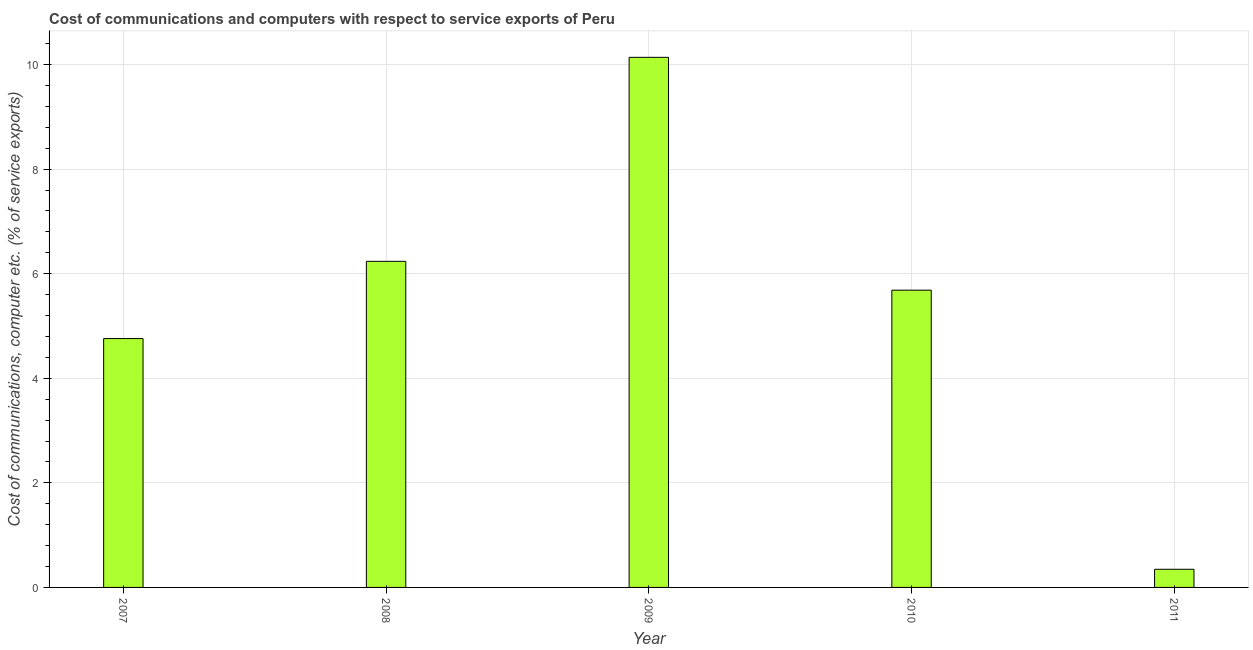Does the graph contain grids?
Give a very brief answer. Yes. What is the title of the graph?
Provide a succinct answer. Cost of communications and computers with respect to service exports of Peru. What is the label or title of the Y-axis?
Offer a very short reply. Cost of communications, computer etc. (% of service exports). What is the cost of communications and computer in 2011?
Your response must be concise. 0.35. Across all years, what is the maximum cost of communications and computer?
Offer a terse response. 10.14. Across all years, what is the minimum cost of communications and computer?
Provide a succinct answer. 0.35. In which year was the cost of communications and computer maximum?
Offer a terse response. 2009. In which year was the cost of communications and computer minimum?
Offer a very short reply. 2011. What is the sum of the cost of communications and computer?
Your response must be concise. 27.17. What is the difference between the cost of communications and computer in 2008 and 2010?
Offer a terse response. 0.55. What is the average cost of communications and computer per year?
Make the answer very short. 5.43. What is the median cost of communications and computer?
Give a very brief answer. 5.69. In how many years, is the cost of communications and computer greater than 5.2 %?
Offer a very short reply. 3. What is the ratio of the cost of communications and computer in 2010 to that in 2011?
Provide a short and direct response. 16.37. Is the cost of communications and computer in 2007 less than that in 2011?
Provide a short and direct response. No. Is the difference between the cost of communications and computer in 2010 and 2011 greater than the difference between any two years?
Provide a short and direct response. No. What is the difference between the highest and the second highest cost of communications and computer?
Your answer should be very brief. 3.9. What is the difference between the highest and the lowest cost of communications and computer?
Give a very brief answer. 9.79. In how many years, is the cost of communications and computer greater than the average cost of communications and computer taken over all years?
Offer a terse response. 3. Are all the bars in the graph horizontal?
Offer a very short reply. No. How many years are there in the graph?
Keep it short and to the point. 5. What is the difference between two consecutive major ticks on the Y-axis?
Provide a short and direct response. 2. What is the Cost of communications, computer etc. (% of service exports) of 2007?
Give a very brief answer. 4.76. What is the Cost of communications, computer etc. (% of service exports) of 2008?
Offer a very short reply. 6.24. What is the Cost of communications, computer etc. (% of service exports) in 2009?
Your answer should be very brief. 10.14. What is the Cost of communications, computer etc. (% of service exports) in 2010?
Give a very brief answer. 5.69. What is the Cost of communications, computer etc. (% of service exports) of 2011?
Provide a succinct answer. 0.35. What is the difference between the Cost of communications, computer etc. (% of service exports) in 2007 and 2008?
Your answer should be compact. -1.48. What is the difference between the Cost of communications, computer etc. (% of service exports) in 2007 and 2009?
Your response must be concise. -5.38. What is the difference between the Cost of communications, computer etc. (% of service exports) in 2007 and 2010?
Ensure brevity in your answer.  -0.93. What is the difference between the Cost of communications, computer etc. (% of service exports) in 2007 and 2011?
Offer a terse response. 4.41. What is the difference between the Cost of communications, computer etc. (% of service exports) in 2008 and 2009?
Your answer should be very brief. -3.9. What is the difference between the Cost of communications, computer etc. (% of service exports) in 2008 and 2010?
Ensure brevity in your answer.  0.55. What is the difference between the Cost of communications, computer etc. (% of service exports) in 2008 and 2011?
Ensure brevity in your answer.  5.89. What is the difference between the Cost of communications, computer etc. (% of service exports) in 2009 and 2010?
Give a very brief answer. 4.45. What is the difference between the Cost of communications, computer etc. (% of service exports) in 2009 and 2011?
Make the answer very short. 9.79. What is the difference between the Cost of communications, computer etc. (% of service exports) in 2010 and 2011?
Your response must be concise. 5.34. What is the ratio of the Cost of communications, computer etc. (% of service exports) in 2007 to that in 2008?
Offer a very short reply. 0.76. What is the ratio of the Cost of communications, computer etc. (% of service exports) in 2007 to that in 2009?
Make the answer very short. 0.47. What is the ratio of the Cost of communications, computer etc. (% of service exports) in 2007 to that in 2010?
Make the answer very short. 0.84. What is the ratio of the Cost of communications, computer etc. (% of service exports) in 2007 to that in 2011?
Offer a very short reply. 13.7. What is the ratio of the Cost of communications, computer etc. (% of service exports) in 2008 to that in 2009?
Your answer should be compact. 0.61. What is the ratio of the Cost of communications, computer etc. (% of service exports) in 2008 to that in 2010?
Your response must be concise. 1.1. What is the ratio of the Cost of communications, computer etc. (% of service exports) in 2008 to that in 2011?
Offer a very short reply. 17.96. What is the ratio of the Cost of communications, computer etc. (% of service exports) in 2009 to that in 2010?
Provide a succinct answer. 1.78. What is the ratio of the Cost of communications, computer etc. (% of service exports) in 2009 to that in 2011?
Provide a succinct answer. 29.19. What is the ratio of the Cost of communications, computer etc. (% of service exports) in 2010 to that in 2011?
Give a very brief answer. 16.37. 